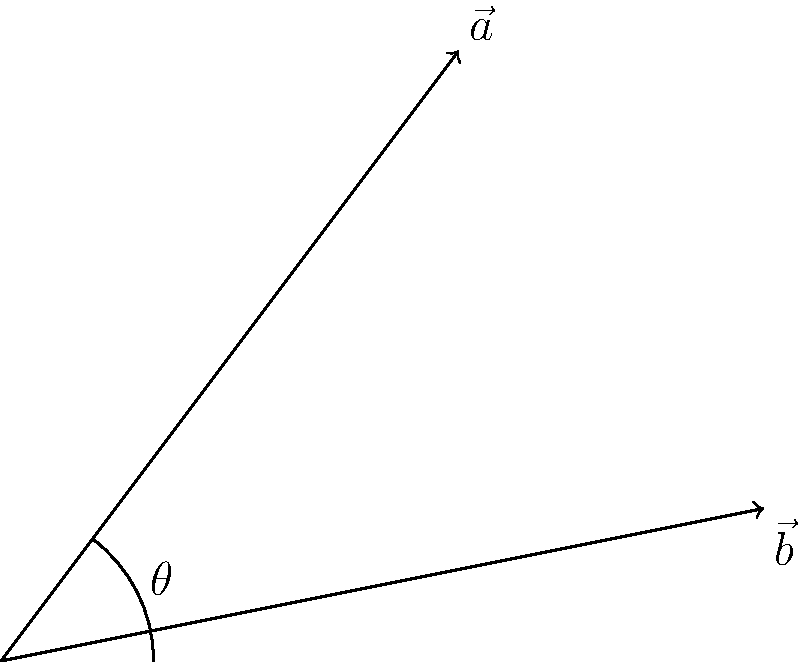During a naval exercise, two aircraft depart from the same carrier but follow different flight paths. The first aircraft's vector is represented by $\vec{a} = 3\hat{i} + 4\hat{j}$, while the second aircraft's vector is given by $\vec{b} = 5\hat{i} + \hat{j}$. What is the angle between these two flight paths? To find the angle between two vectors, we can use the dot product formula:

$$\cos \theta = \frac{\vec{a} \cdot \vec{b}}{|\vec{a}||\vec{b}|}$$

Step 1: Calculate the dot product $\vec{a} \cdot \vec{b}$
$$\vec{a} \cdot \vec{b} = (3)(5) + (4)(1) = 15 + 4 = 19$$

Step 2: Calculate the magnitudes of $\vec{a}$ and $\vec{b}$
$$|\vec{a}| = \sqrt{3^2 + 4^2} = \sqrt{9 + 16} = \sqrt{25} = 5$$
$$|\vec{b}| = \sqrt{5^2 + 1^2} = \sqrt{25 + 1} = \sqrt{26}$$

Step 3: Substitute into the formula
$$\cos \theta = \frac{19}{5\sqrt{26}}$$

Step 4: Take the inverse cosine (arccos) of both sides
$$\theta = \arccos\left(\frac{19}{5\sqrt{26}}\right)$$

Step 5: Calculate the result (rounded to two decimal places)
$$\theta \approx 0.37 \text{ radians}$$

Convert to degrees:
$$\theta \approx 0.37 \times \frac{180°}{\pi} \approx 21.17°$$
Answer: $21.17°$ 